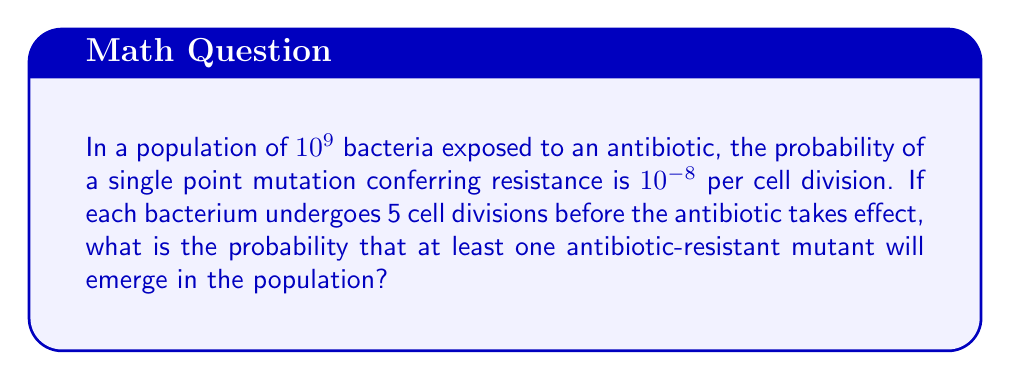Teach me how to tackle this problem. Let's approach this step-by-step:

1) First, we need to calculate the probability of a single bacterium not developing resistance after 5 cell divisions.

   Probability of no mutation in one division = $1 - 10^{-8}$
   Probability of no mutation in 5 divisions = $(1 - 10^{-8})^5$

2) Now, we can calculate the probability of a single bacterium developing resistance:

   $P(\text{resistance in one bacterium}) = 1 - (1 - 10^{-8})^5$

3) The probability of no resistant bacteria in the entire population is:

   $P(\text{no resistance}) = [(1 - 10^{-8})^5]^{10^9}$

4) Therefore, the probability of at least one resistant bacterium is:

   $P(\text{at least one resistant}) = 1 - [(1 - 10^{-8})^5]^{10^9}$

5) Let's calculate this:

   $[(1 - 10^{-8})^5]^{10^9} = (1 - 5 \times 10^{-8})^{10^9}$ (using binomial approximation)

   $= e^{10^9 \ln(1 - 5 \times 10^{-8})} \approx e^{-50}$ (using $\ln(1-x) \approx -x$ for small $x$)

6) Thus, the final probability is:

   $P(\text{at least one resistant}) = 1 - e^{-50} \approx 1 - 1.9287 \times 10^{-22}$
Answer: The probability of at least one antibiotic-resistant mutant emerging is approximately 0.9999999999999999999998, or 99.99999999999999999998%. 